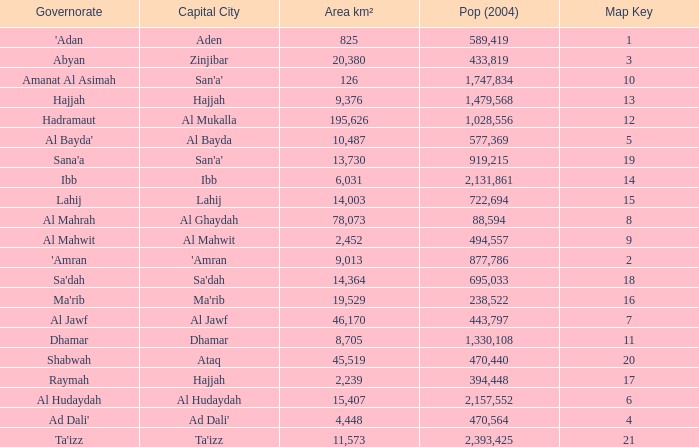How many Pop (2004) has a Governorate of al mahwit? 494557.0. 